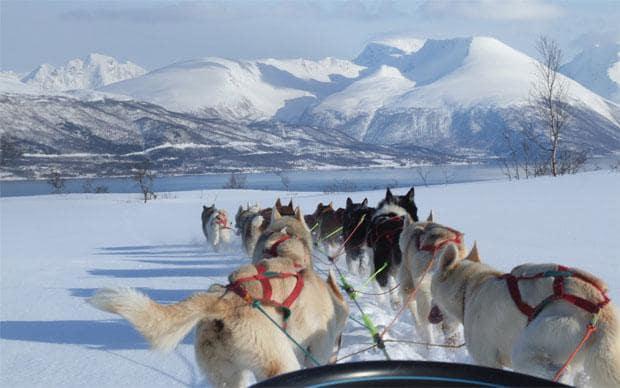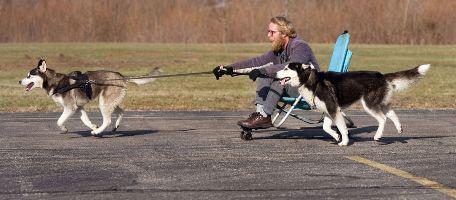The first image is the image on the left, the second image is the image on the right. Examine the images to the left and right. Is the description "Both images show at least one sled pulled by no more than five dogs." accurate? Answer yes or no. No. The first image is the image on the left, the second image is the image on the right. For the images shown, is this caption "The combined images contain three teams of sled dogs running forward across the snow instead of away from the camera." true? Answer yes or no. No. 